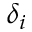Convert formula to latex. <formula><loc_0><loc_0><loc_500><loc_500>\delta _ { i }</formula> 